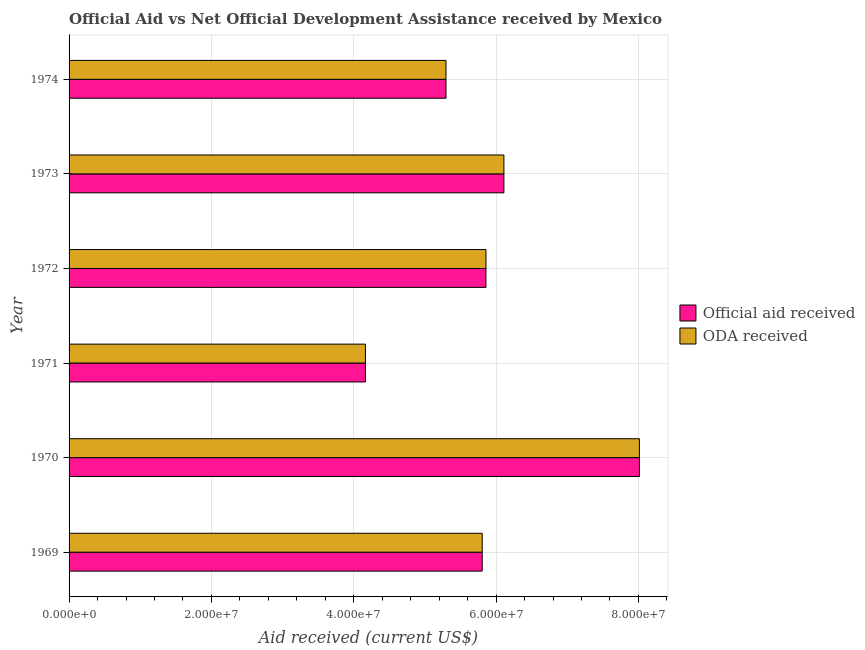How many different coloured bars are there?
Give a very brief answer. 2. How many groups of bars are there?
Provide a short and direct response. 6. Are the number of bars per tick equal to the number of legend labels?
Give a very brief answer. Yes. What is the label of the 6th group of bars from the top?
Offer a terse response. 1969. What is the oda received in 1972?
Provide a succinct answer. 5.86e+07. Across all years, what is the maximum official aid received?
Make the answer very short. 8.01e+07. Across all years, what is the minimum official aid received?
Your response must be concise. 4.16e+07. In which year was the oda received maximum?
Give a very brief answer. 1970. In which year was the official aid received minimum?
Offer a terse response. 1971. What is the total official aid received in the graph?
Your answer should be very brief. 3.52e+08. What is the difference between the official aid received in 1972 and that in 1973?
Your answer should be very brief. -2.52e+06. What is the difference between the official aid received in 1974 and the oda received in 1969?
Provide a short and direct response. -5.09e+06. What is the average official aid received per year?
Your response must be concise. 5.87e+07. In the year 1971, what is the difference between the official aid received and oda received?
Give a very brief answer. 0. In how many years, is the oda received greater than 28000000 US$?
Your response must be concise. 6. What is the ratio of the oda received in 1971 to that in 1973?
Ensure brevity in your answer.  0.68. Is the official aid received in 1970 less than that in 1973?
Provide a succinct answer. No. What is the difference between the highest and the second highest oda received?
Keep it short and to the point. 1.90e+07. What is the difference between the highest and the lowest oda received?
Keep it short and to the point. 3.85e+07. What does the 2nd bar from the top in 1969 represents?
Offer a terse response. Official aid received. What does the 2nd bar from the bottom in 1971 represents?
Ensure brevity in your answer.  ODA received. Are all the bars in the graph horizontal?
Provide a succinct answer. Yes. How many legend labels are there?
Your response must be concise. 2. How are the legend labels stacked?
Keep it short and to the point. Vertical. What is the title of the graph?
Give a very brief answer. Official Aid vs Net Official Development Assistance received by Mexico . Does "IMF concessional" appear as one of the legend labels in the graph?
Provide a short and direct response. No. What is the label or title of the X-axis?
Make the answer very short. Aid received (current US$). What is the label or title of the Y-axis?
Your answer should be compact. Year. What is the Aid received (current US$) of Official aid received in 1969?
Provide a succinct answer. 5.80e+07. What is the Aid received (current US$) of ODA received in 1969?
Make the answer very short. 5.80e+07. What is the Aid received (current US$) of Official aid received in 1970?
Ensure brevity in your answer.  8.01e+07. What is the Aid received (current US$) in ODA received in 1970?
Your answer should be compact. 8.01e+07. What is the Aid received (current US$) of Official aid received in 1971?
Ensure brevity in your answer.  4.16e+07. What is the Aid received (current US$) of ODA received in 1971?
Offer a terse response. 4.16e+07. What is the Aid received (current US$) in Official aid received in 1972?
Keep it short and to the point. 5.86e+07. What is the Aid received (current US$) of ODA received in 1972?
Give a very brief answer. 5.86e+07. What is the Aid received (current US$) of Official aid received in 1973?
Make the answer very short. 6.11e+07. What is the Aid received (current US$) in ODA received in 1973?
Ensure brevity in your answer.  6.11e+07. What is the Aid received (current US$) of Official aid received in 1974?
Give a very brief answer. 5.30e+07. What is the Aid received (current US$) in ODA received in 1974?
Give a very brief answer. 5.30e+07. Across all years, what is the maximum Aid received (current US$) of Official aid received?
Your answer should be compact. 8.01e+07. Across all years, what is the maximum Aid received (current US$) in ODA received?
Offer a terse response. 8.01e+07. Across all years, what is the minimum Aid received (current US$) in Official aid received?
Your answer should be compact. 4.16e+07. Across all years, what is the minimum Aid received (current US$) of ODA received?
Your answer should be compact. 4.16e+07. What is the total Aid received (current US$) in Official aid received in the graph?
Offer a terse response. 3.52e+08. What is the total Aid received (current US$) in ODA received in the graph?
Keep it short and to the point. 3.52e+08. What is the difference between the Aid received (current US$) of Official aid received in 1969 and that in 1970?
Keep it short and to the point. -2.21e+07. What is the difference between the Aid received (current US$) in ODA received in 1969 and that in 1970?
Ensure brevity in your answer.  -2.21e+07. What is the difference between the Aid received (current US$) in Official aid received in 1969 and that in 1971?
Your response must be concise. 1.64e+07. What is the difference between the Aid received (current US$) of ODA received in 1969 and that in 1971?
Make the answer very short. 1.64e+07. What is the difference between the Aid received (current US$) in Official aid received in 1969 and that in 1972?
Offer a very short reply. -5.30e+05. What is the difference between the Aid received (current US$) in ODA received in 1969 and that in 1972?
Your answer should be very brief. -5.30e+05. What is the difference between the Aid received (current US$) in Official aid received in 1969 and that in 1973?
Keep it short and to the point. -3.05e+06. What is the difference between the Aid received (current US$) of ODA received in 1969 and that in 1973?
Your response must be concise. -3.05e+06. What is the difference between the Aid received (current US$) in Official aid received in 1969 and that in 1974?
Ensure brevity in your answer.  5.09e+06. What is the difference between the Aid received (current US$) of ODA received in 1969 and that in 1974?
Offer a terse response. 5.09e+06. What is the difference between the Aid received (current US$) of Official aid received in 1970 and that in 1971?
Your answer should be very brief. 3.85e+07. What is the difference between the Aid received (current US$) of ODA received in 1970 and that in 1971?
Provide a short and direct response. 3.85e+07. What is the difference between the Aid received (current US$) of Official aid received in 1970 and that in 1972?
Make the answer very short. 2.16e+07. What is the difference between the Aid received (current US$) in ODA received in 1970 and that in 1972?
Offer a very short reply. 2.16e+07. What is the difference between the Aid received (current US$) of Official aid received in 1970 and that in 1973?
Offer a very short reply. 1.90e+07. What is the difference between the Aid received (current US$) in ODA received in 1970 and that in 1973?
Your answer should be very brief. 1.90e+07. What is the difference between the Aid received (current US$) of Official aid received in 1970 and that in 1974?
Offer a very short reply. 2.72e+07. What is the difference between the Aid received (current US$) in ODA received in 1970 and that in 1974?
Provide a short and direct response. 2.72e+07. What is the difference between the Aid received (current US$) in Official aid received in 1971 and that in 1972?
Your response must be concise. -1.69e+07. What is the difference between the Aid received (current US$) of ODA received in 1971 and that in 1972?
Ensure brevity in your answer.  -1.69e+07. What is the difference between the Aid received (current US$) in Official aid received in 1971 and that in 1973?
Ensure brevity in your answer.  -1.95e+07. What is the difference between the Aid received (current US$) in ODA received in 1971 and that in 1973?
Offer a very short reply. -1.95e+07. What is the difference between the Aid received (current US$) in Official aid received in 1971 and that in 1974?
Provide a succinct answer. -1.13e+07. What is the difference between the Aid received (current US$) in ODA received in 1971 and that in 1974?
Your response must be concise. -1.13e+07. What is the difference between the Aid received (current US$) in Official aid received in 1972 and that in 1973?
Your answer should be compact. -2.52e+06. What is the difference between the Aid received (current US$) of ODA received in 1972 and that in 1973?
Offer a very short reply. -2.52e+06. What is the difference between the Aid received (current US$) in Official aid received in 1972 and that in 1974?
Make the answer very short. 5.62e+06. What is the difference between the Aid received (current US$) in ODA received in 1972 and that in 1974?
Your answer should be very brief. 5.62e+06. What is the difference between the Aid received (current US$) of Official aid received in 1973 and that in 1974?
Ensure brevity in your answer.  8.14e+06. What is the difference between the Aid received (current US$) of ODA received in 1973 and that in 1974?
Make the answer very short. 8.14e+06. What is the difference between the Aid received (current US$) of Official aid received in 1969 and the Aid received (current US$) of ODA received in 1970?
Your answer should be very brief. -2.21e+07. What is the difference between the Aid received (current US$) in Official aid received in 1969 and the Aid received (current US$) in ODA received in 1971?
Your answer should be very brief. 1.64e+07. What is the difference between the Aid received (current US$) of Official aid received in 1969 and the Aid received (current US$) of ODA received in 1972?
Offer a very short reply. -5.30e+05. What is the difference between the Aid received (current US$) in Official aid received in 1969 and the Aid received (current US$) in ODA received in 1973?
Provide a succinct answer. -3.05e+06. What is the difference between the Aid received (current US$) of Official aid received in 1969 and the Aid received (current US$) of ODA received in 1974?
Make the answer very short. 5.09e+06. What is the difference between the Aid received (current US$) of Official aid received in 1970 and the Aid received (current US$) of ODA received in 1971?
Provide a short and direct response. 3.85e+07. What is the difference between the Aid received (current US$) of Official aid received in 1970 and the Aid received (current US$) of ODA received in 1972?
Provide a short and direct response. 2.16e+07. What is the difference between the Aid received (current US$) of Official aid received in 1970 and the Aid received (current US$) of ODA received in 1973?
Provide a short and direct response. 1.90e+07. What is the difference between the Aid received (current US$) of Official aid received in 1970 and the Aid received (current US$) of ODA received in 1974?
Provide a short and direct response. 2.72e+07. What is the difference between the Aid received (current US$) in Official aid received in 1971 and the Aid received (current US$) in ODA received in 1972?
Your response must be concise. -1.69e+07. What is the difference between the Aid received (current US$) in Official aid received in 1971 and the Aid received (current US$) in ODA received in 1973?
Ensure brevity in your answer.  -1.95e+07. What is the difference between the Aid received (current US$) in Official aid received in 1971 and the Aid received (current US$) in ODA received in 1974?
Your answer should be very brief. -1.13e+07. What is the difference between the Aid received (current US$) of Official aid received in 1972 and the Aid received (current US$) of ODA received in 1973?
Keep it short and to the point. -2.52e+06. What is the difference between the Aid received (current US$) of Official aid received in 1972 and the Aid received (current US$) of ODA received in 1974?
Provide a succinct answer. 5.62e+06. What is the difference between the Aid received (current US$) in Official aid received in 1973 and the Aid received (current US$) in ODA received in 1974?
Offer a terse response. 8.14e+06. What is the average Aid received (current US$) in Official aid received per year?
Ensure brevity in your answer.  5.87e+07. What is the average Aid received (current US$) of ODA received per year?
Offer a very short reply. 5.87e+07. In the year 1971, what is the difference between the Aid received (current US$) of Official aid received and Aid received (current US$) of ODA received?
Provide a short and direct response. 0. In the year 1974, what is the difference between the Aid received (current US$) in Official aid received and Aid received (current US$) in ODA received?
Your response must be concise. 0. What is the ratio of the Aid received (current US$) in Official aid received in 1969 to that in 1970?
Ensure brevity in your answer.  0.72. What is the ratio of the Aid received (current US$) of ODA received in 1969 to that in 1970?
Give a very brief answer. 0.72. What is the ratio of the Aid received (current US$) of Official aid received in 1969 to that in 1971?
Provide a succinct answer. 1.39. What is the ratio of the Aid received (current US$) of ODA received in 1969 to that in 1971?
Provide a succinct answer. 1.39. What is the ratio of the Aid received (current US$) in Official aid received in 1969 to that in 1973?
Provide a succinct answer. 0.95. What is the ratio of the Aid received (current US$) in ODA received in 1969 to that in 1973?
Give a very brief answer. 0.95. What is the ratio of the Aid received (current US$) in Official aid received in 1969 to that in 1974?
Provide a succinct answer. 1.1. What is the ratio of the Aid received (current US$) in ODA received in 1969 to that in 1974?
Give a very brief answer. 1.1. What is the ratio of the Aid received (current US$) of Official aid received in 1970 to that in 1971?
Provide a short and direct response. 1.92. What is the ratio of the Aid received (current US$) in ODA received in 1970 to that in 1971?
Provide a succinct answer. 1.92. What is the ratio of the Aid received (current US$) of Official aid received in 1970 to that in 1972?
Make the answer very short. 1.37. What is the ratio of the Aid received (current US$) of ODA received in 1970 to that in 1972?
Your response must be concise. 1.37. What is the ratio of the Aid received (current US$) of Official aid received in 1970 to that in 1973?
Your answer should be compact. 1.31. What is the ratio of the Aid received (current US$) in ODA received in 1970 to that in 1973?
Give a very brief answer. 1.31. What is the ratio of the Aid received (current US$) of Official aid received in 1970 to that in 1974?
Make the answer very short. 1.51. What is the ratio of the Aid received (current US$) in ODA received in 1970 to that in 1974?
Provide a short and direct response. 1.51. What is the ratio of the Aid received (current US$) in Official aid received in 1971 to that in 1972?
Give a very brief answer. 0.71. What is the ratio of the Aid received (current US$) in ODA received in 1971 to that in 1972?
Provide a short and direct response. 0.71. What is the ratio of the Aid received (current US$) in Official aid received in 1971 to that in 1973?
Ensure brevity in your answer.  0.68. What is the ratio of the Aid received (current US$) of ODA received in 1971 to that in 1973?
Your response must be concise. 0.68. What is the ratio of the Aid received (current US$) of Official aid received in 1971 to that in 1974?
Your answer should be compact. 0.79. What is the ratio of the Aid received (current US$) in ODA received in 1971 to that in 1974?
Offer a terse response. 0.79. What is the ratio of the Aid received (current US$) in Official aid received in 1972 to that in 1973?
Your answer should be very brief. 0.96. What is the ratio of the Aid received (current US$) in ODA received in 1972 to that in 1973?
Make the answer very short. 0.96. What is the ratio of the Aid received (current US$) in Official aid received in 1972 to that in 1974?
Provide a short and direct response. 1.11. What is the ratio of the Aid received (current US$) of ODA received in 1972 to that in 1974?
Your answer should be compact. 1.11. What is the ratio of the Aid received (current US$) of Official aid received in 1973 to that in 1974?
Your answer should be very brief. 1.15. What is the ratio of the Aid received (current US$) of ODA received in 1973 to that in 1974?
Your response must be concise. 1.15. What is the difference between the highest and the second highest Aid received (current US$) in Official aid received?
Your answer should be compact. 1.90e+07. What is the difference between the highest and the second highest Aid received (current US$) in ODA received?
Provide a short and direct response. 1.90e+07. What is the difference between the highest and the lowest Aid received (current US$) of Official aid received?
Provide a succinct answer. 3.85e+07. What is the difference between the highest and the lowest Aid received (current US$) in ODA received?
Ensure brevity in your answer.  3.85e+07. 